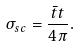<formula> <loc_0><loc_0><loc_500><loc_500>\sigma _ { s c } = \frac { \bar { t } t } { 4 \pi } .</formula> 